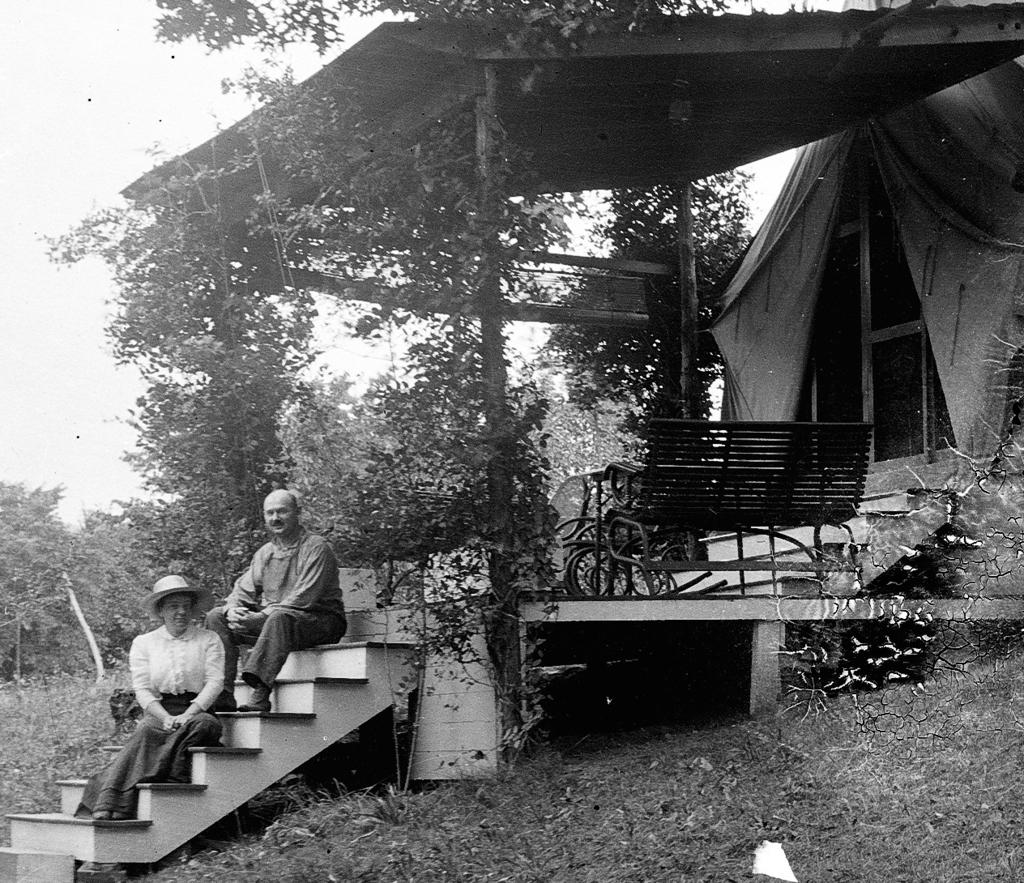What is the color scheme of the image? The image is black and white. What type of structure can be seen in the image? There is a house in the image. What type of vegetation is present in the image? There are trees and plants in the image. What type of seating is available in the image? There are benches in the image. What architectural feature is present in the image? There are stairs in the image. Are there any people in the image? Yes, there are persons in the image. What type of ground surface is visible in the image? There is grass in the image. What part of the natural environment is visible in the image? The sky is visible in the image. What type of taste can be experienced from the moon in the image? There is no moon present in the image, and therefore no taste can be experienced from it. How many pigs are visible in the image? There are no pigs present in the image. 